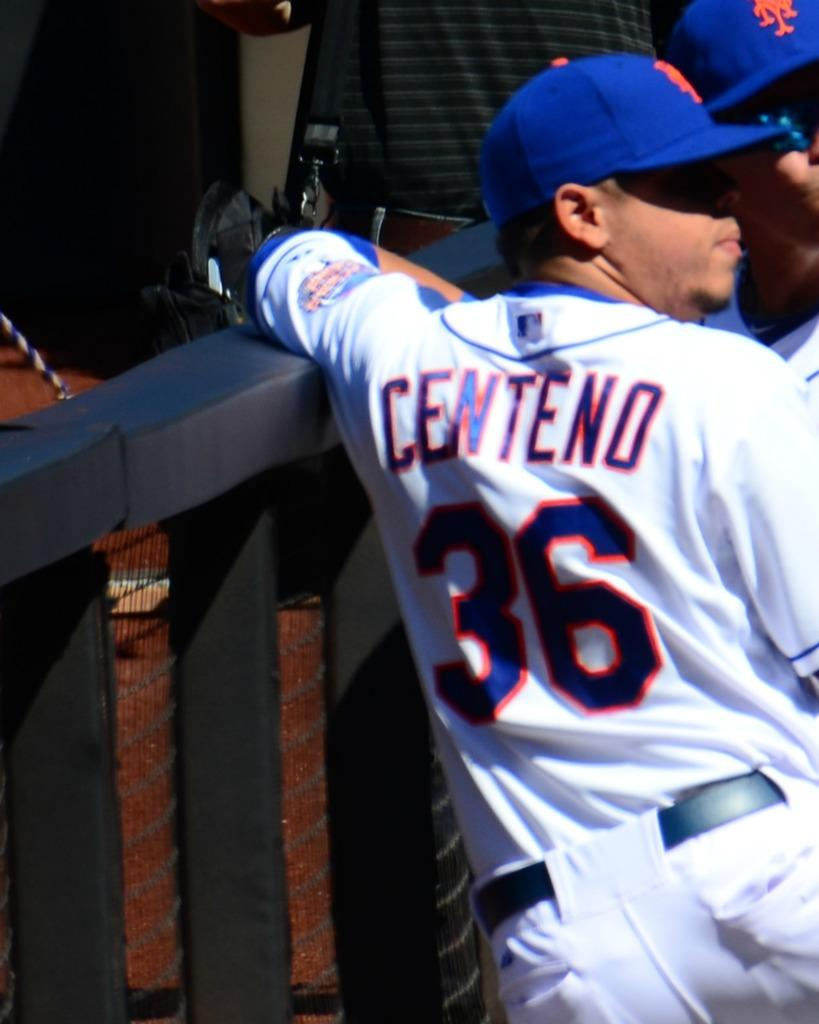<image>
Render a clear and concise summary of the photo. number 36 centeno in white mets uniform with blue cap looks on with another teammate 